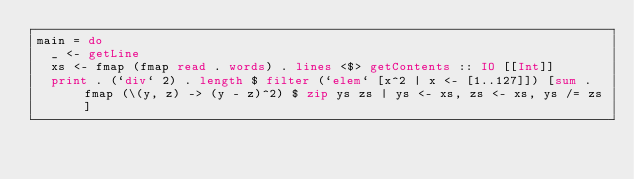Convert code to text. <code><loc_0><loc_0><loc_500><loc_500><_Haskell_>main = do
  _ <- getLine
  xs <- fmap (fmap read . words) . lines <$> getContents :: IO [[Int]]
  print . (`div` 2) . length $ filter (`elem` [x^2 | x <- [1..127]]) [sum . fmap (\(y, z) -> (y - z)^2) $ zip ys zs | ys <- xs, zs <- xs, ys /= zs]
</code> 